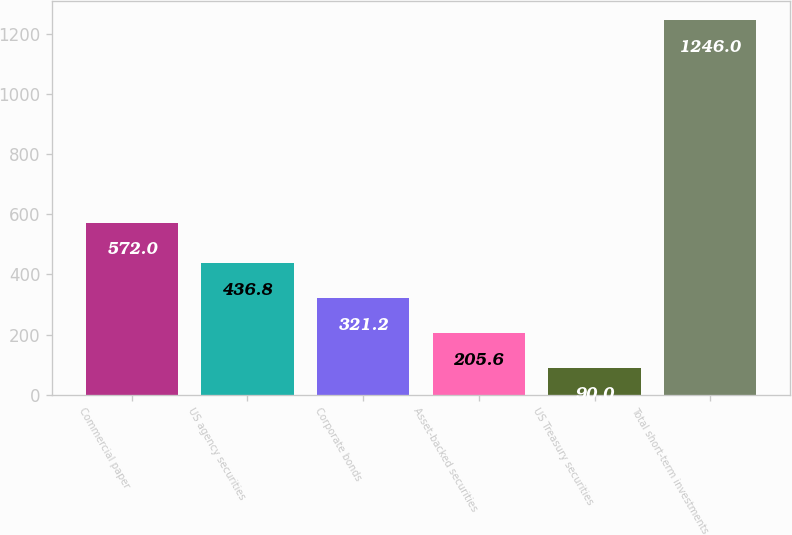<chart> <loc_0><loc_0><loc_500><loc_500><bar_chart><fcel>Commercial paper<fcel>US agency securities<fcel>Corporate bonds<fcel>Asset-backed securities<fcel>US Treasury securities<fcel>Total short-term investments<nl><fcel>572<fcel>436.8<fcel>321.2<fcel>205.6<fcel>90<fcel>1246<nl></chart> 